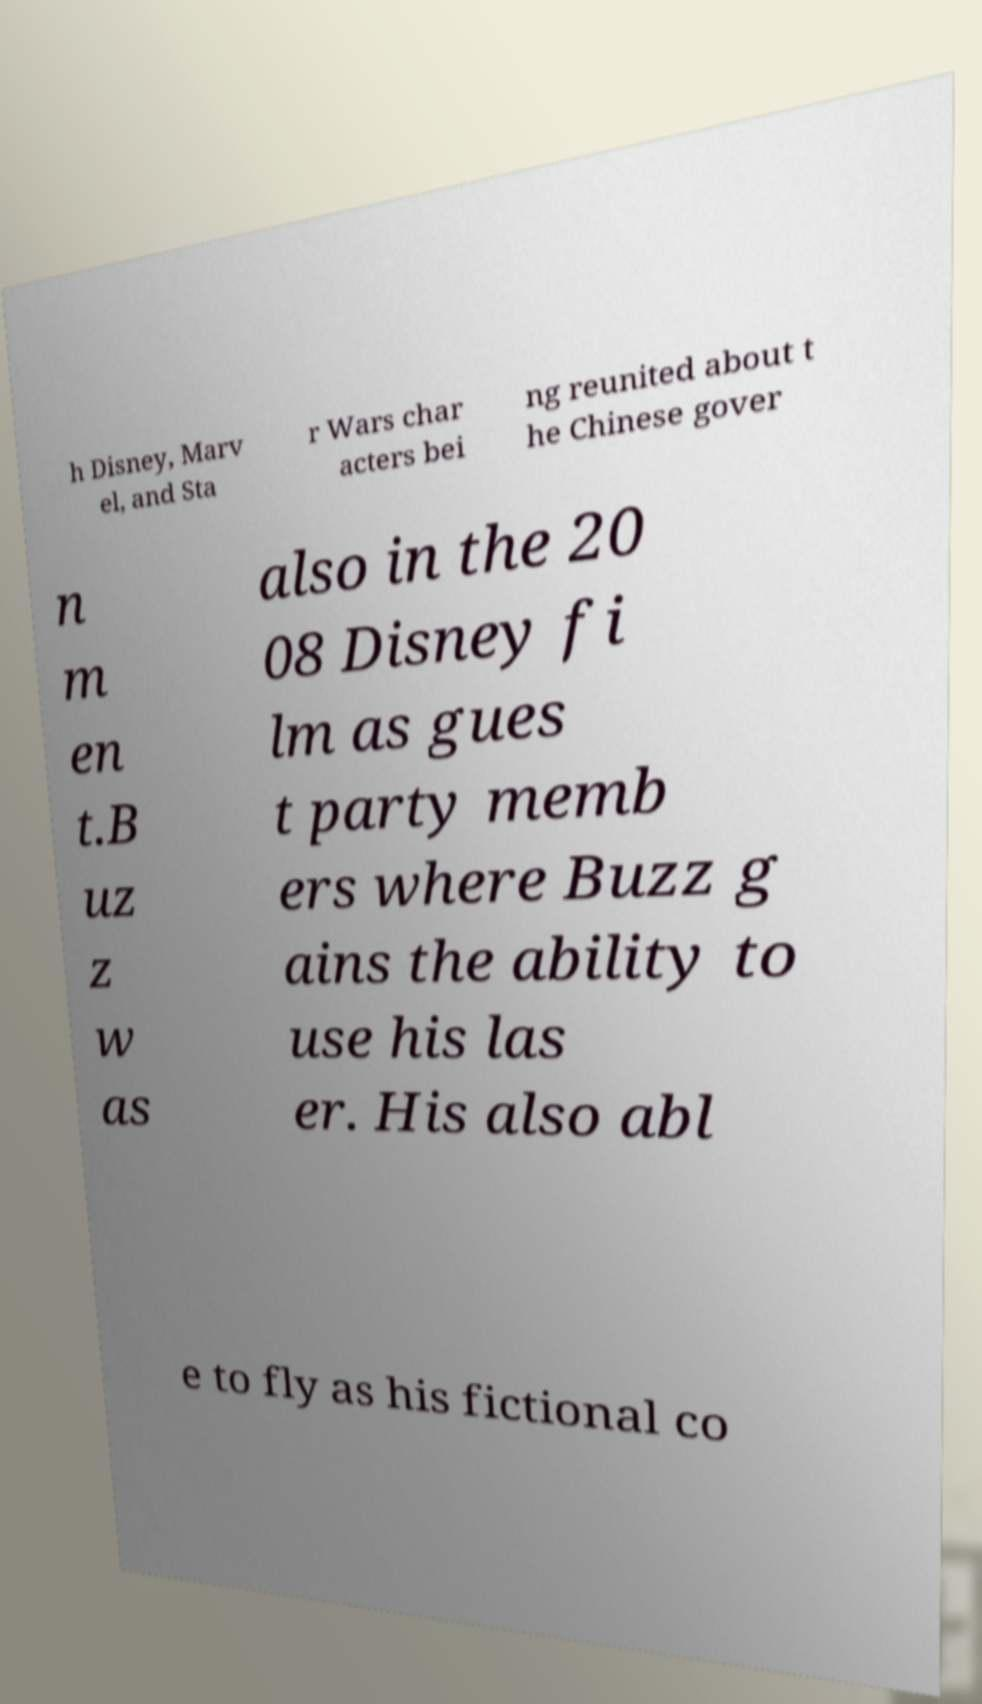Could you extract and type out the text from this image? h Disney, Marv el, and Sta r Wars char acters bei ng reunited about t he Chinese gover n m en t.B uz z w as also in the 20 08 Disney fi lm as gues t party memb ers where Buzz g ains the ability to use his las er. His also abl e to fly as his fictional co 